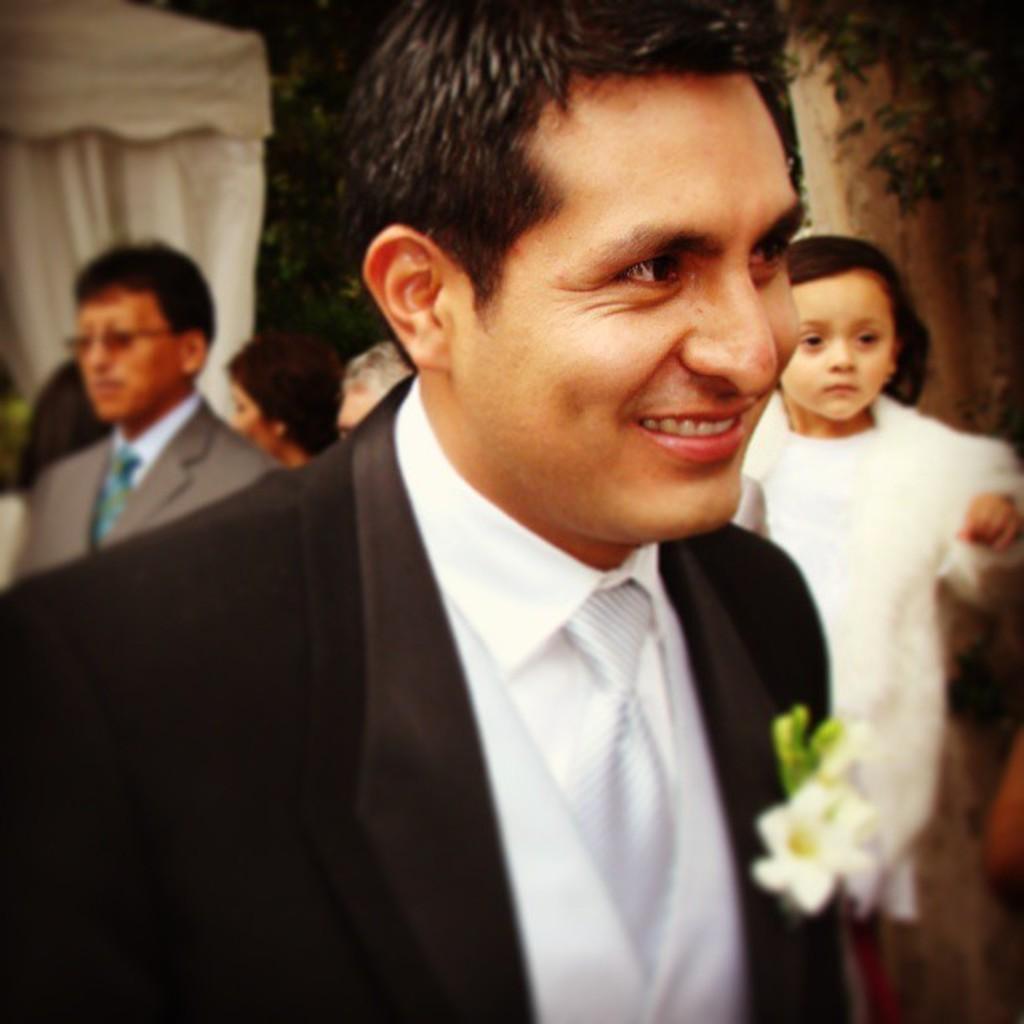Can you describe this image briefly? There is a person wearing tie and a black coat is smiling. On the coast there is a flower. In the back there's a girl and few people. 